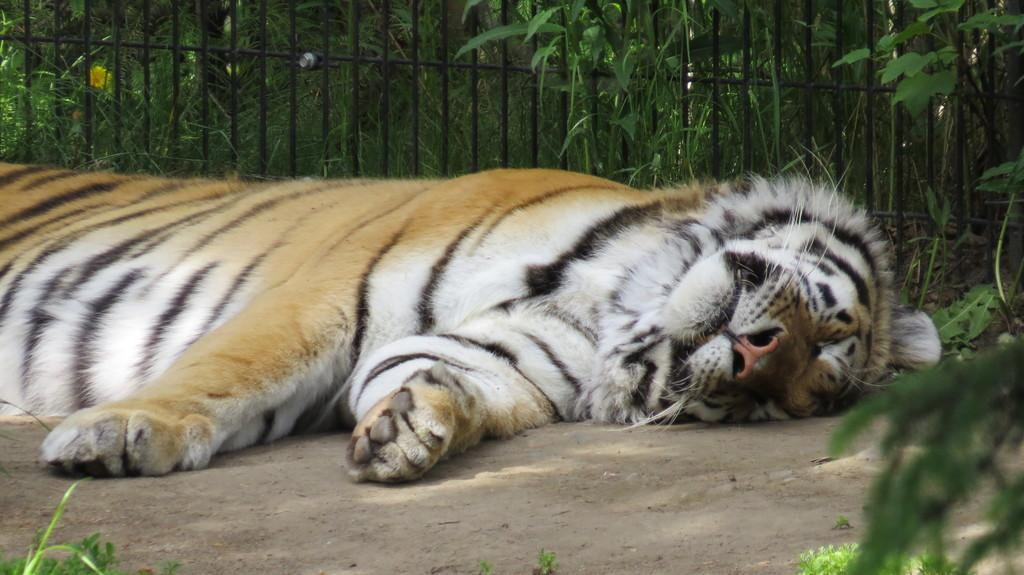What animal can be seen in the image? There is a tiger in the image. What is the tiger doing in the image? The tiger is sleeping on the ground. What type of surface is the tiger resting on? There is ground visible in the image. What can be seen in the background of the image? There are plants and a metal grill in the background of the image. What type of boot can be seen on the tiger's wrist in the image? There is no boot or wrist visible in the image; it features a tiger sleeping on the ground with plants and a metal grill in the background. 